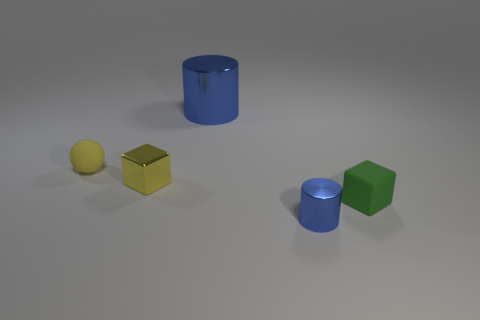There is a blue object that is the same size as the green rubber block; what is its shape?
Provide a short and direct response. Cylinder. Does the block left of the small green matte block have the same material as the thing that is behind the small yellow rubber object?
Your answer should be compact. Yes. How many big yellow matte things are there?
Ensure brevity in your answer.  0. How many other small rubber things have the same shape as the green thing?
Keep it short and to the point. 0. Is the small green thing the same shape as the small yellow metal object?
Your answer should be compact. Yes. The ball is what size?
Keep it short and to the point. Small. How many blue metal objects have the same size as the yellow metal cube?
Keep it short and to the point. 1. There is a metallic object that is behind the tiny yellow rubber thing; does it have the same size as the blue metallic thing in front of the yellow matte object?
Provide a short and direct response. No. What is the shape of the blue thing right of the big metallic cylinder?
Your answer should be very brief. Cylinder. There is a blue object that is behind the thing to the left of the metallic block; what is its material?
Give a very brief answer. Metal. 